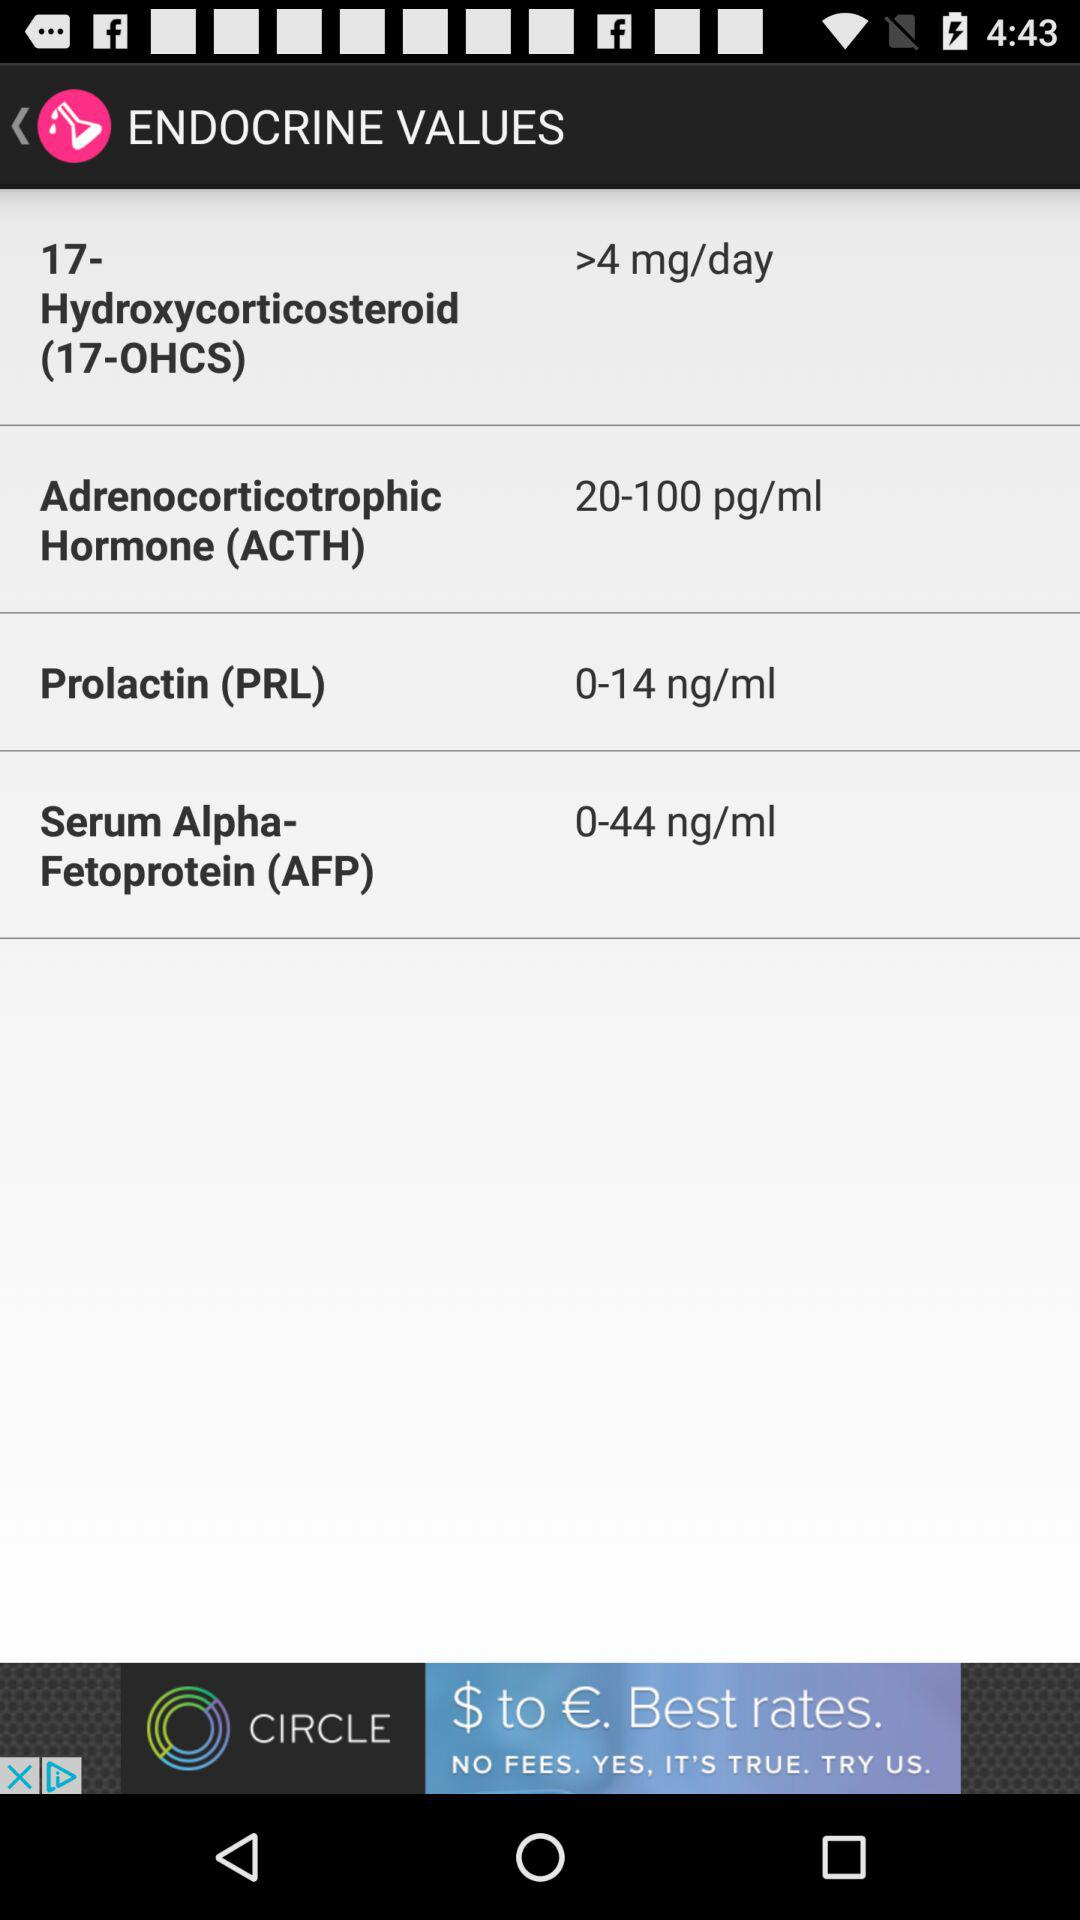What is the value of Serum Alpha-Fetoprotein (AFP) in ml? The value of Serum Alpha-Fetoprotein (AFP) is 0-44 ng/ml. 